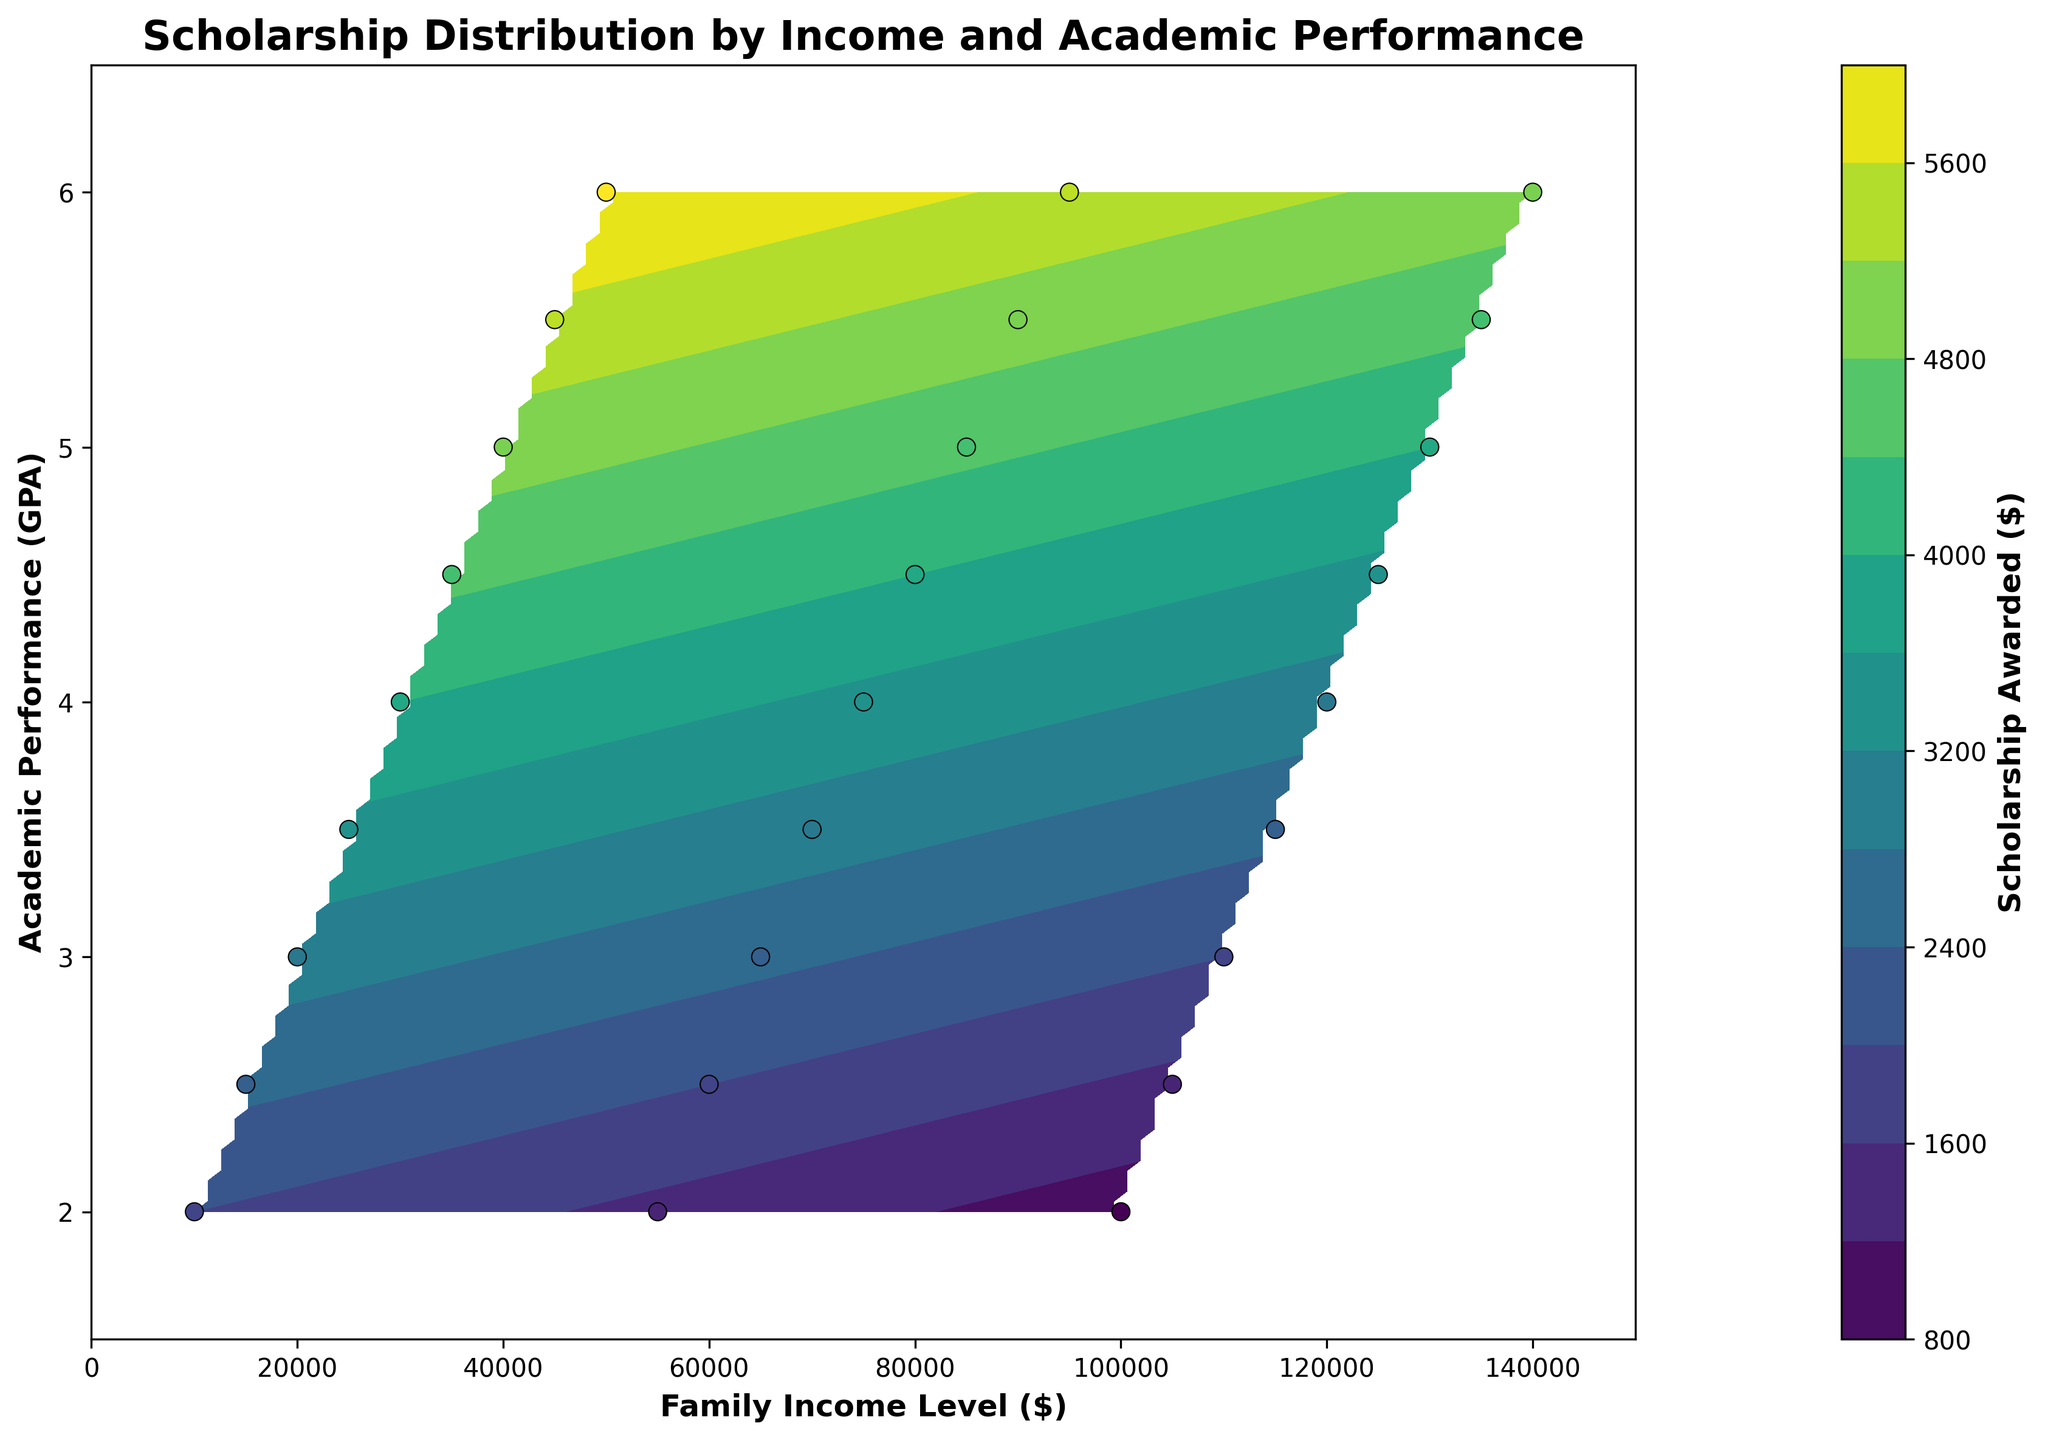What is the title of the figure? The title is usually positioned at the top of the figure and is written in bold. By looking at the top of the plot, you can see the text displayed.
Answer: Scholarship Distribution by Income and Academic Performance What does the color bar represent in this contour plot? The color bar is usually placed on the side of the contour plot and indicates what the colors within the contour plot represent. By reading the label next to the color bar, you can determine what it signifies.
Answer: Scholarship Awarded ($) Which family income level corresponds to the highest scholarship awarded? To find the highest scholarship awarded, look for the darkest region on the contour plot, which represents the highest values according to the color bar, and then check the corresponding family income level on the x-axis.
Answer: $50,000 What are the labels of the x-axis and y-axis? The labels for the axes can be found along the x-axis (horizontal) and y-axis (vertical). They tell you what each axis represents.
Answer: Family Income Level ($), Academic Performance (GPA) Within which range of academic performance do students seem to receive the most scholarships? Based on the contour plot, the areas with the highest scholarship values are shown in the darkest colors. Locate the dark regions and identify the range of academic performance on the y-axis.
Answer: 4.0 to 6.0 GPA If a student has a family income of $80,000 and a GPA of 4.5, approximately how much scholarship are they awarded? To determine the scholarship awarded, find the point where $80,000 on the x-axis intersects 4.5 on the y-axis, then look at the color and refer to the color bar to estimate the scholarship amount.
Answer: Approximately $4,000 Compare the scholarships awarded to two students, one with a family income of $30,000 and a GPA of 4.0, and another with a family income of $110,000 and a GPA of 3.0. Who receives a higher scholarship and by how much? Find the scholarship amounts for the first student by locating the intersection of $30,000 on the x-axis and 4.0 GPA on the y-axis, and similarly for the second student. Then subtract the two values to find the difference. Student 1: $4,000, Student 2: $2,000, Difference = $4,000 - $2,000 = $2,000
Answer: Student with $30,000 family income receives $2,000 more In terms of family income, what is the trend of scholarship awarded as income increases, considering students with a GPA of 5.0? To identify the trend, follow the line at GPA 5.0 on the y-axis and observe the color changes as the family income values increase on the x-axis. Darker shades should indicate decreasing scholarship values as income increases.
Answer: Decreases How consistent is the scholarship distribution for students with varying academic performances but a constant family income of $70,000? Find the vertical line at $70,000 family income on the x-axis and observe the color distribution along this line from the lowest to the highest GPA values. Notice how the colors vary to assess the consistency.
Answer: Generally consistent, with slight increases What family income level appears to be the threshold below which students with lower GPAs receive a significant scholarship amount compared to those with higher GPAs? Locate the lower GPAs (around 2.0) on the y-axis and see where the color starts to significantly change (usually becomes lighter as income increases). This threshold point indicates the income level where the scholarship begins to significantly drop.
Answer: Around $55,000 